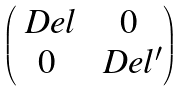<formula> <loc_0><loc_0><loc_500><loc_500>\begin{pmatrix} \ D e l & 0 \\ 0 & \ D e l ^ { \prime } \end{pmatrix}</formula> 